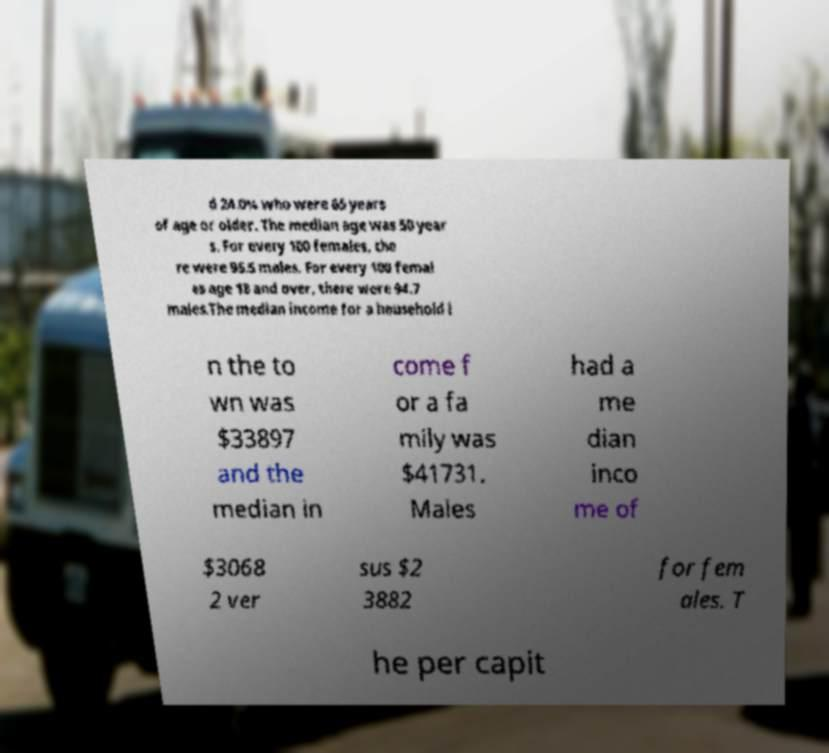Please identify and transcribe the text found in this image. d 24.0% who were 65 years of age or older. The median age was 50 year s. For every 100 females, the re were 95.5 males. For every 100 femal es age 18 and over, there were 94.7 males.The median income for a household i n the to wn was $33897 and the median in come f or a fa mily was $41731. Males had a me dian inco me of $3068 2 ver sus $2 3882 for fem ales. T he per capit 